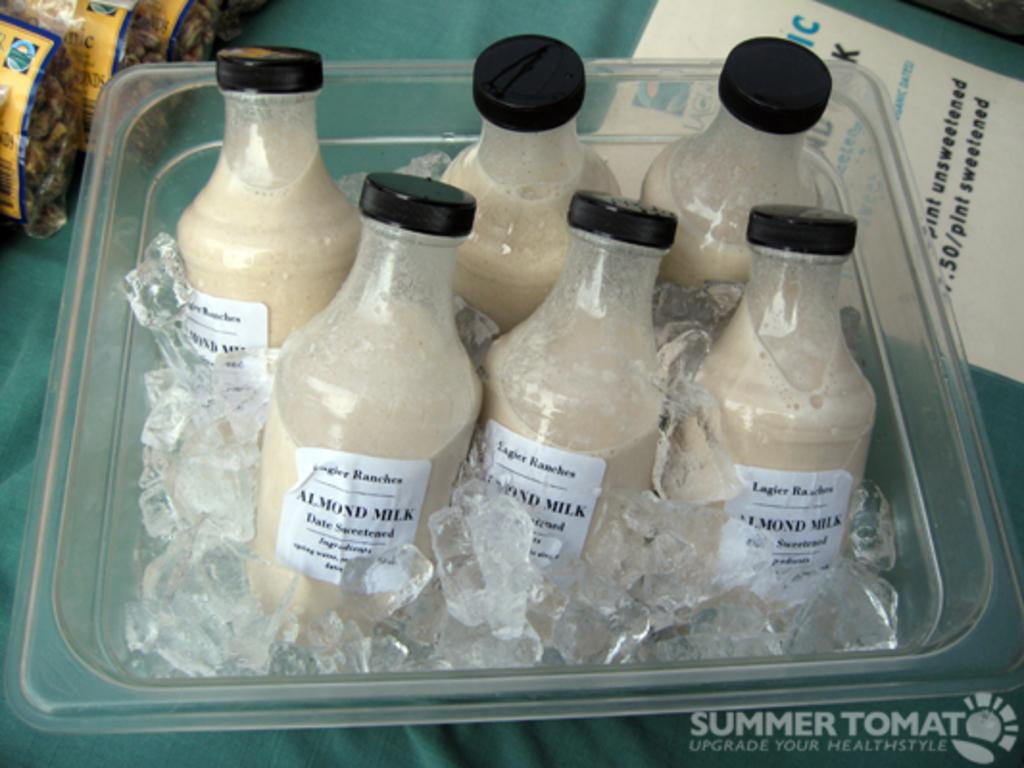<image>
Write a terse but informative summary of the picture. Six small bottles of almond milk sit in a container full of ice. 